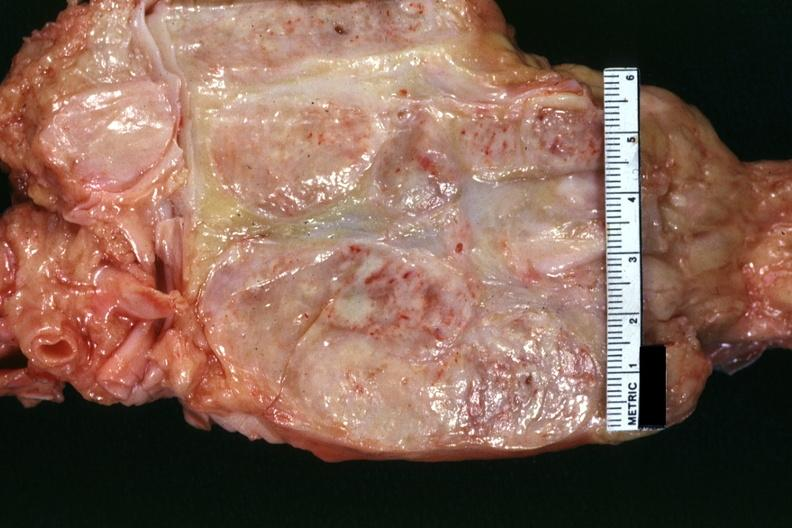what cut surface of nodes seen externally in slide shows matting and focal necrosis?
Answer the question using a single word or phrase. Excellent example 